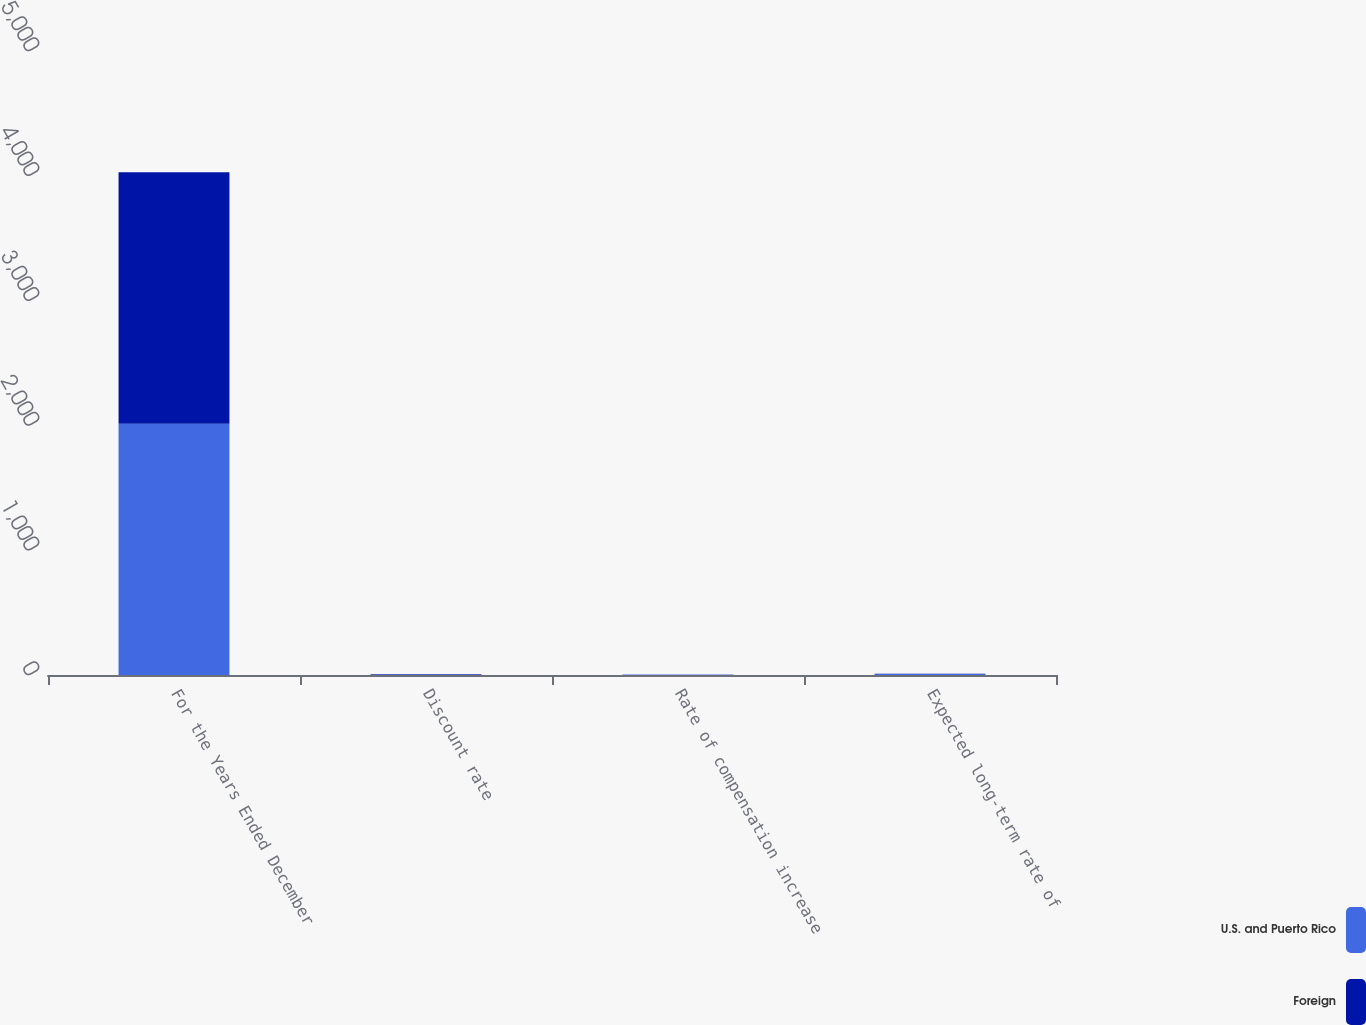<chart> <loc_0><loc_0><loc_500><loc_500><stacked_bar_chart><ecel><fcel>For the Years Ended December<fcel>Discount rate<fcel>Rate of compensation increase<fcel>Expected long-term rate of<nl><fcel>U.S. and Puerto Rico<fcel>2014<fcel>4.98<fcel>3.29<fcel>7.75<nl><fcel>Foreign<fcel>2014<fcel>2.46<fcel>1.48<fcel>2.88<nl></chart> 